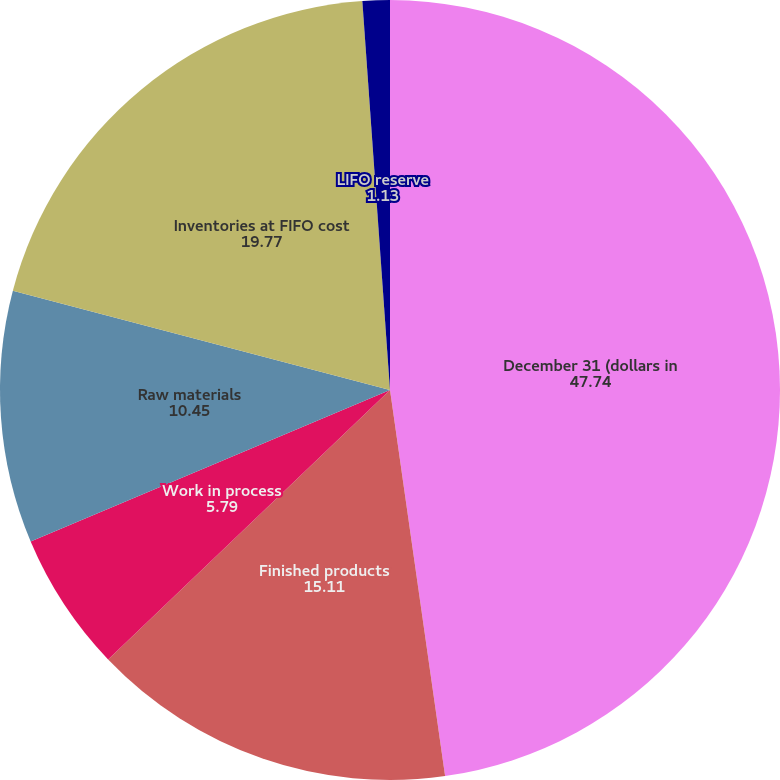Convert chart. <chart><loc_0><loc_0><loc_500><loc_500><pie_chart><fcel>December 31 (dollars in<fcel>Finished products<fcel>Work in process<fcel>Raw materials<fcel>Inventories at FIFO cost<fcel>LIFO reserve<nl><fcel>47.74%<fcel>15.11%<fcel>5.79%<fcel>10.45%<fcel>19.77%<fcel>1.13%<nl></chart> 